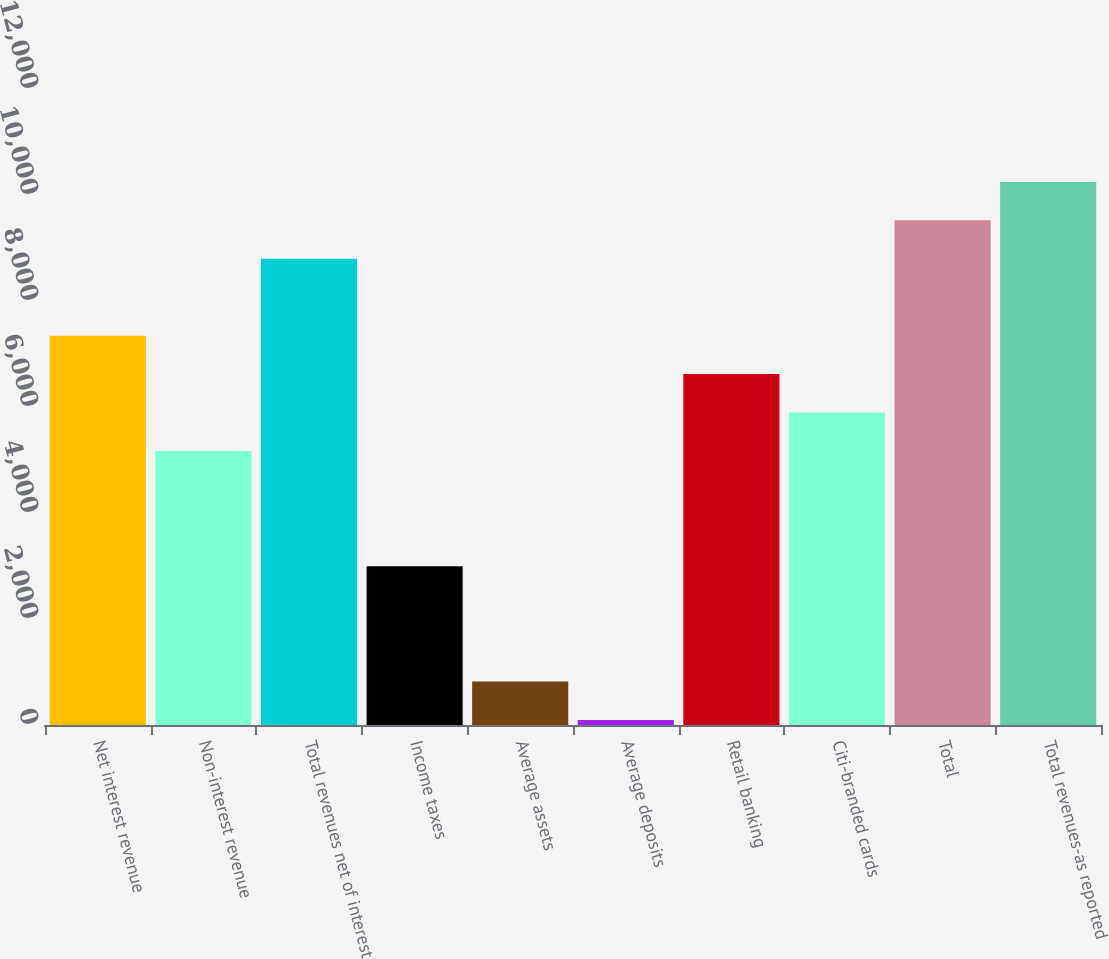Convert chart to OTSL. <chart><loc_0><loc_0><loc_500><loc_500><bar_chart><fcel>Net interest revenue<fcel>Non-interest revenue<fcel>Total revenues net of interest<fcel>Income taxes<fcel>Average assets<fcel>Average deposits<fcel>Retail banking<fcel>Citi-branded cards<fcel>Total<fcel>Total revenues-as reported<nl><fcel>7346<fcel>5170.58<fcel>8796.28<fcel>2995.16<fcel>819.74<fcel>94.6<fcel>6620.86<fcel>5895.72<fcel>9521.42<fcel>10246.6<nl></chart> 